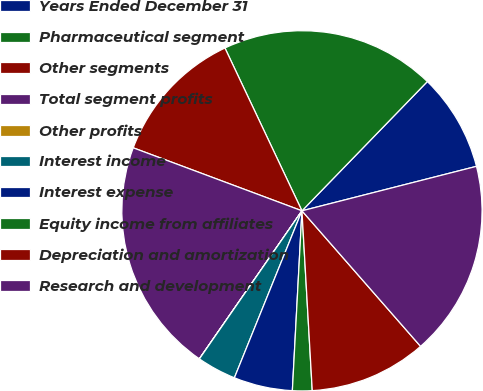<chart> <loc_0><loc_0><loc_500><loc_500><pie_chart><fcel>Years Ended December 31<fcel>Pharmaceutical segment<fcel>Other segments<fcel>Total segment profits<fcel>Other profits<fcel>Interest income<fcel>Interest expense<fcel>Equity income from affiliates<fcel>Depreciation and amortization<fcel>Research and development<nl><fcel>8.77%<fcel>19.29%<fcel>12.28%<fcel>21.04%<fcel>0.01%<fcel>3.52%<fcel>5.27%<fcel>1.76%<fcel>10.53%<fcel>17.53%<nl></chart> 